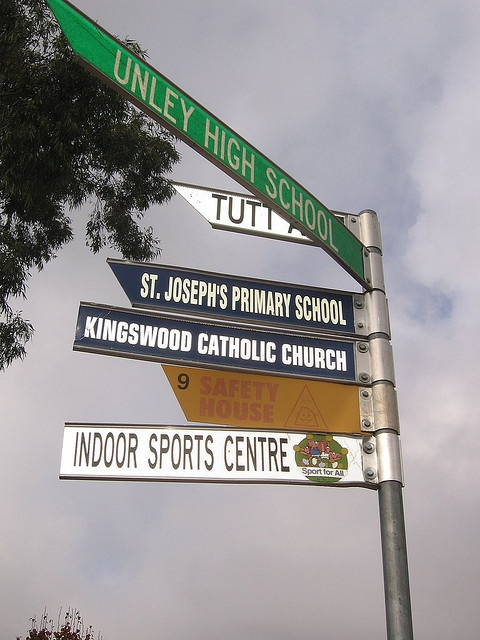Describe the objects in this image and their specific colors. I can see various objects in this image with different colors. 